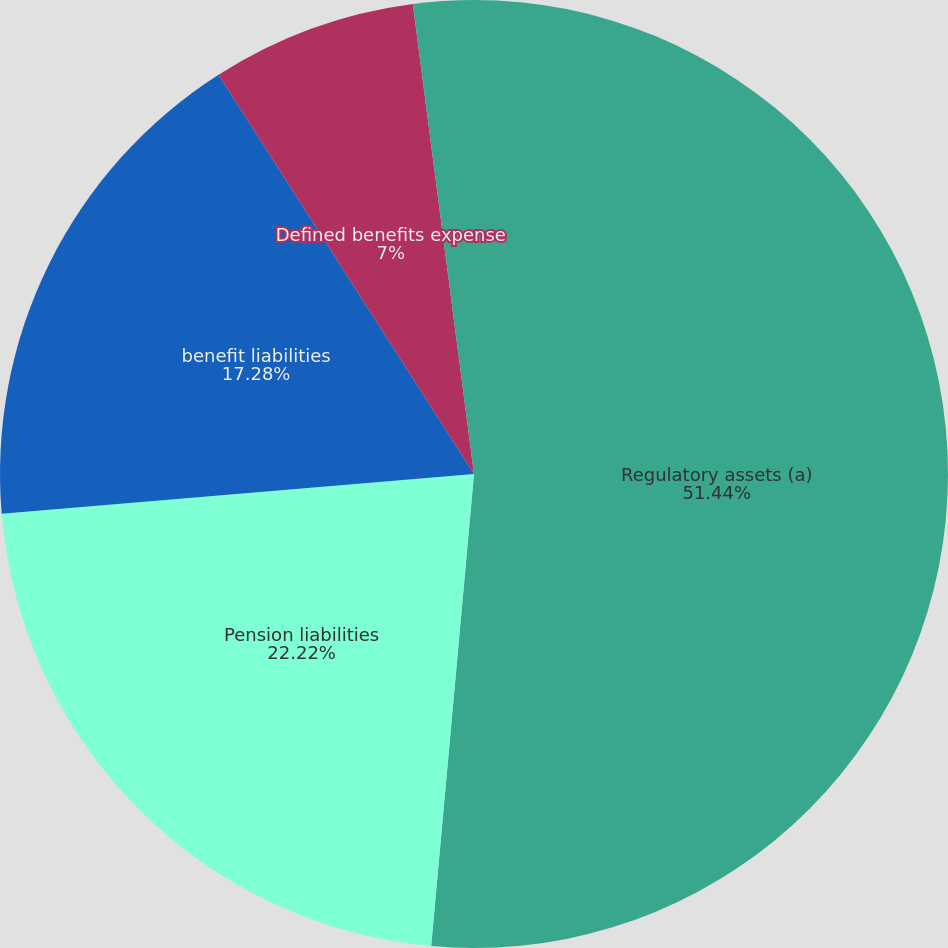Convert chart to OTSL. <chart><loc_0><loc_0><loc_500><loc_500><pie_chart><fcel>Regulatory assets (a)<fcel>Pension liabilities<fcel>benefit liabilities<fcel>Defined benefits expense<fcel>Increase (decrease) from prior<nl><fcel>51.44%<fcel>22.22%<fcel>17.28%<fcel>7.0%<fcel>2.06%<nl></chart> 